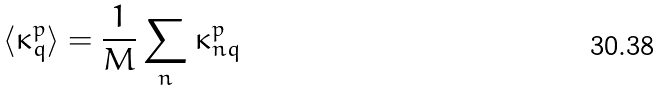Convert formula to latex. <formula><loc_0><loc_0><loc_500><loc_500>\langle \kappa _ { q } ^ { p } \rangle = \frac { 1 } { M } \sum _ { n } \kappa _ { n q } ^ { p }</formula> 